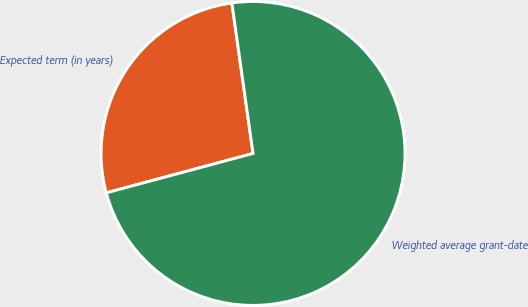Convert chart to OTSL. <chart><loc_0><loc_0><loc_500><loc_500><pie_chart><fcel>Expected term (in years)<fcel>Weighted average grant-date<nl><fcel>26.95%<fcel>73.05%<nl></chart> 